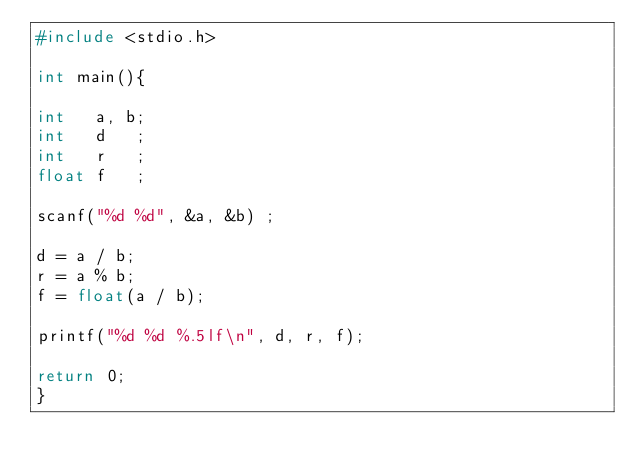<code> <loc_0><loc_0><loc_500><loc_500><_C_>#include <stdio.h>

int main(){

int   a, b; 
int   d   ; 
int   r   ; 
float f   ; 

scanf("%d %d", &a, &b) ;

d = a / b;
r = a % b;
f = float(a / b);

printf("%d %d %.5lf\n", d, r, f);

return 0;
}</code> 